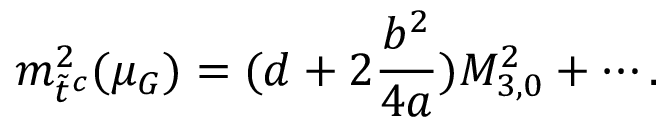<formula> <loc_0><loc_0><loc_500><loc_500>m _ { \tilde { t } ^ { c } } ^ { 2 } ( \mu _ { G } ) = ( d + 2 \frac { b ^ { 2 } } { 4 a } ) M _ { 3 , 0 } ^ { 2 } + \cdots .</formula> 